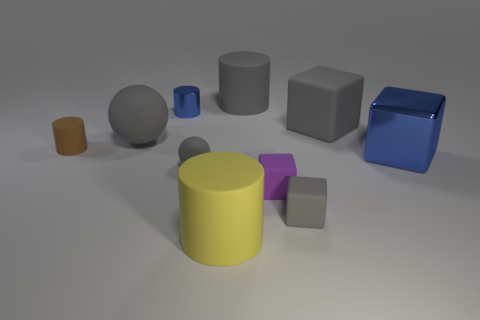Subtract all balls. How many objects are left? 8 Subtract all purple objects. Subtract all brown shiny spheres. How many objects are left? 9 Add 2 big gray balls. How many big gray balls are left? 3 Add 6 large matte cylinders. How many large matte cylinders exist? 8 Subtract 1 purple cubes. How many objects are left? 9 